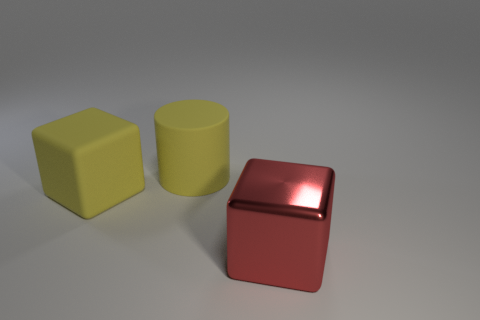Add 2 brown shiny cylinders. How many objects exist? 5 Subtract all yellow cubes. How many cubes are left? 1 Subtract all blocks. How many objects are left? 1 Subtract all big matte cylinders. Subtract all big yellow objects. How many objects are left? 0 Add 3 big red blocks. How many big red blocks are left? 4 Add 1 big rubber cylinders. How many big rubber cylinders exist? 2 Subtract 0 green blocks. How many objects are left? 3 Subtract all brown cylinders. Subtract all purple balls. How many cylinders are left? 1 Subtract all cyan spheres. How many red cubes are left? 1 